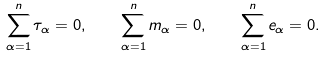<formula> <loc_0><loc_0><loc_500><loc_500>\sum _ { \alpha = 1 } ^ { n } \tau _ { \alpha } = 0 , \quad \sum _ { \alpha = 1 } ^ { n } m _ { \alpha } = 0 , \quad \sum _ { \alpha = 1 } ^ { n } e _ { \alpha } = 0 .</formula> 